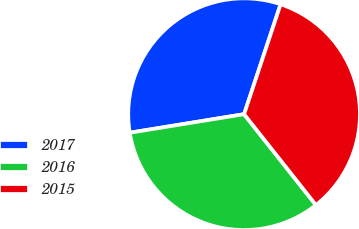Convert chart. <chart><loc_0><loc_0><loc_500><loc_500><pie_chart><fcel>2017<fcel>2016<fcel>2015<nl><fcel>32.66%<fcel>33.09%<fcel>34.25%<nl></chart> 